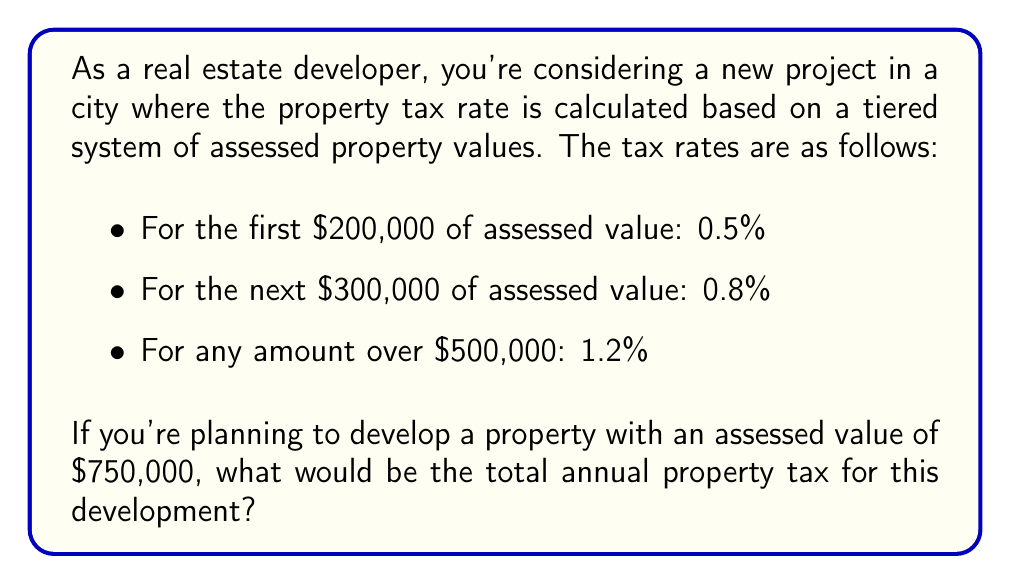Give your solution to this math problem. To calculate the total annual property tax, we need to break down the assessed value into tiers and apply the corresponding tax rates. Let's go through this step-by-step:

1. First tier (0-$200,000):
   Tax = $200,000 * 0.5% = $200,000 * 0.005 = $1,000

2. Second tier ($200,001-$500,000):
   Tax = $300,000 * 0.8% = $300,000 * 0.008 = $2,400

3. Third tier (over $500,000):
   Remaining value = $750,000 - $500,000 = $250,000
   Tax = $250,000 * 1.2% = $250,000 * 0.012 = $3,000

Now, we sum up the taxes from all tiers:

Total annual property tax = $1,000 + $2,400 + $3,000 = $6,400

We can express this mathematically as:

$$\text{Total Tax} = (200,000 \times 0.005) + (300,000 \times 0.008) + (250,000 \times 0.012) = 6,400$$
Answer: $6,400 